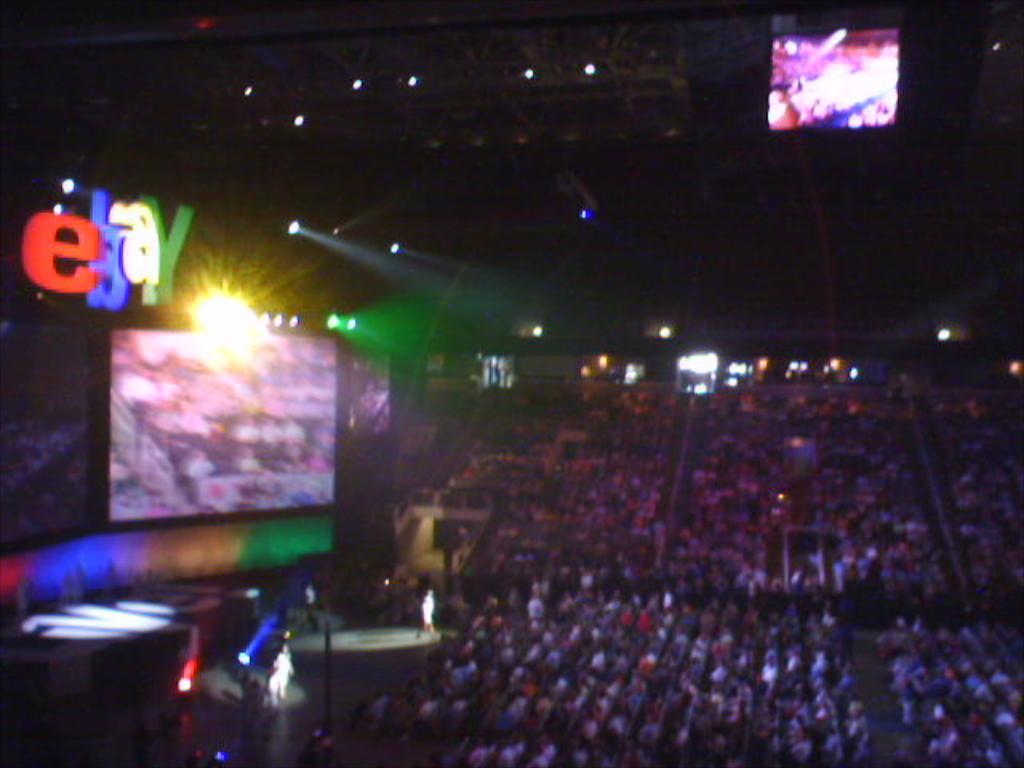What company is above the monitor?
Offer a very short reply. Ebay. What color is the fourth letter above the megatron?
Make the answer very short. Y. 